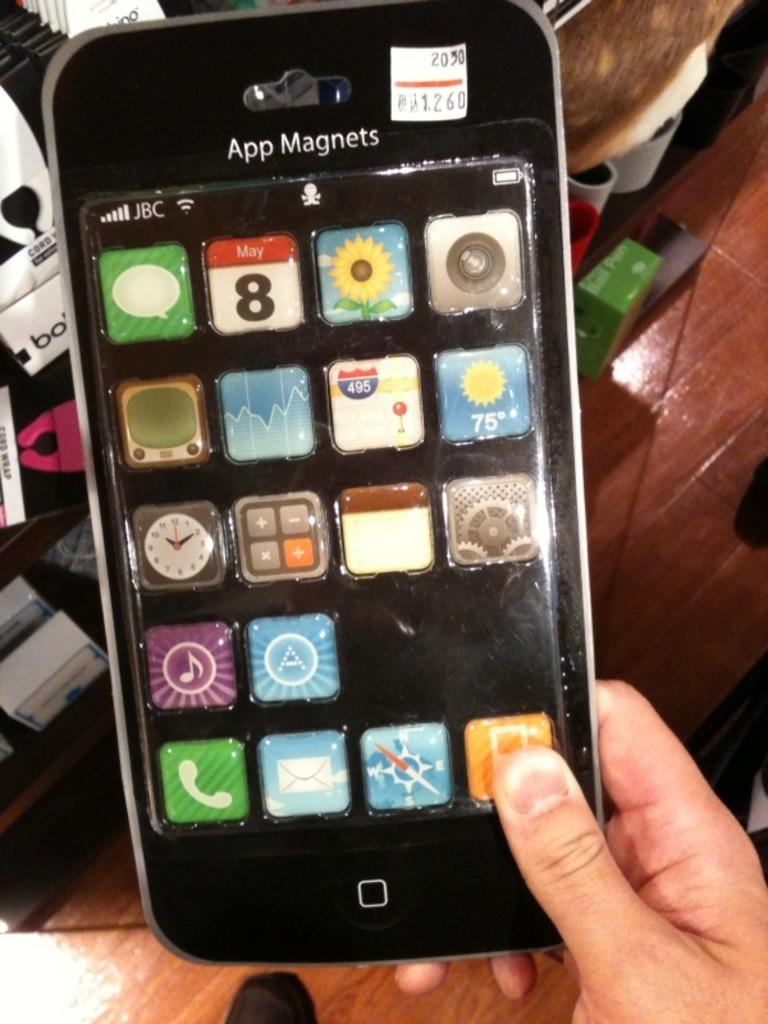Provide a one-sentence caption for the provided image. A person is holding a package of magnets shaped like an iPhone that says App Magnets. 